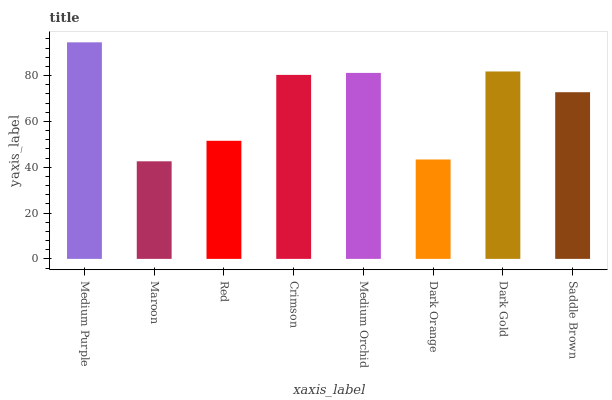Is Maroon the minimum?
Answer yes or no. Yes. Is Medium Purple the maximum?
Answer yes or no. Yes. Is Red the minimum?
Answer yes or no. No. Is Red the maximum?
Answer yes or no. No. Is Red greater than Maroon?
Answer yes or no. Yes. Is Maroon less than Red?
Answer yes or no. Yes. Is Maroon greater than Red?
Answer yes or no. No. Is Red less than Maroon?
Answer yes or no. No. Is Crimson the high median?
Answer yes or no. Yes. Is Saddle Brown the low median?
Answer yes or no. Yes. Is Medium Orchid the high median?
Answer yes or no. No. Is Red the low median?
Answer yes or no. No. 